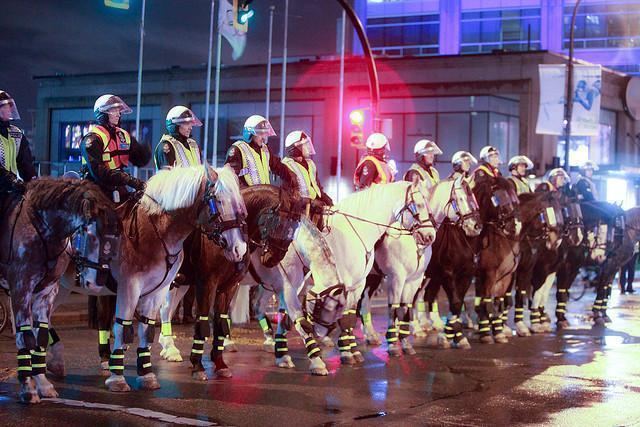What do the officers here observe?
Answer the question by selecting the correct answer among the 4 following choices and explain your choice with a short sentence. The answer should be formatted with the following format: `Answer: choice
Rationale: rationale.`
Options: Party, horse race, candled cake, protest. Answer: protest.
Rationale: The police are in riot gear and are likely at a protest. 